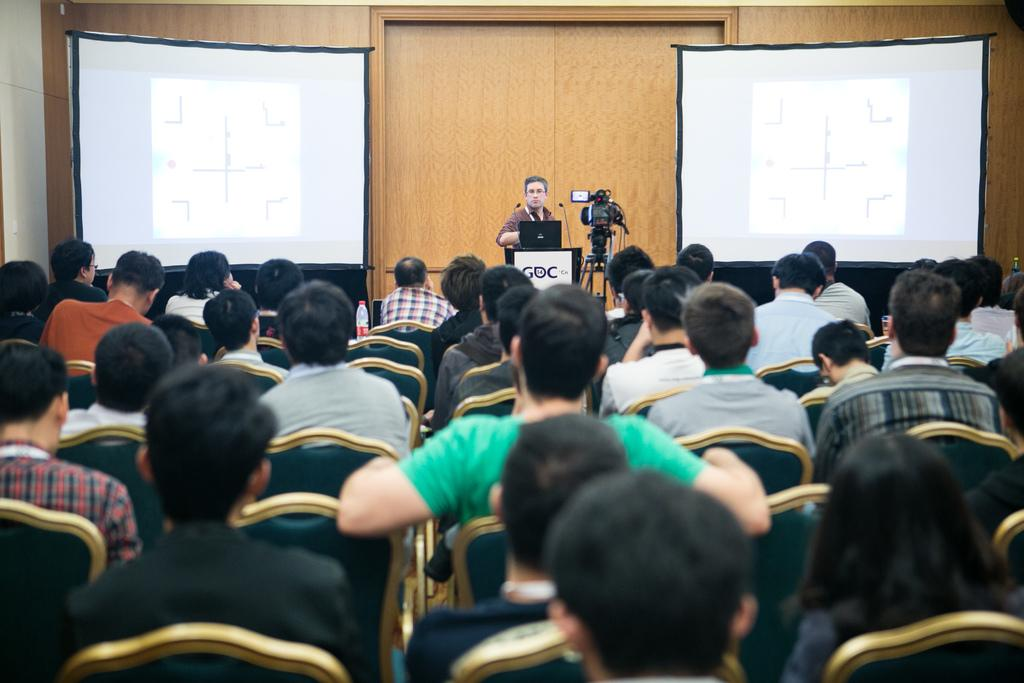How many people are in the image? There is a group of people in the image. What are some of the people in the image doing? Some people are sitting on chairs. What objects can be seen in the background of the image? A: There is a bottle, a laptop, a camera, and projector screens in the background of the image. How many ants are crawling on the laptop in the image? There are no ants visible in the image, and therefore no ants are crawling on the laptop. What decision was made by the group of people in the image? The image does not provide any information about a decision made by the group of people. 